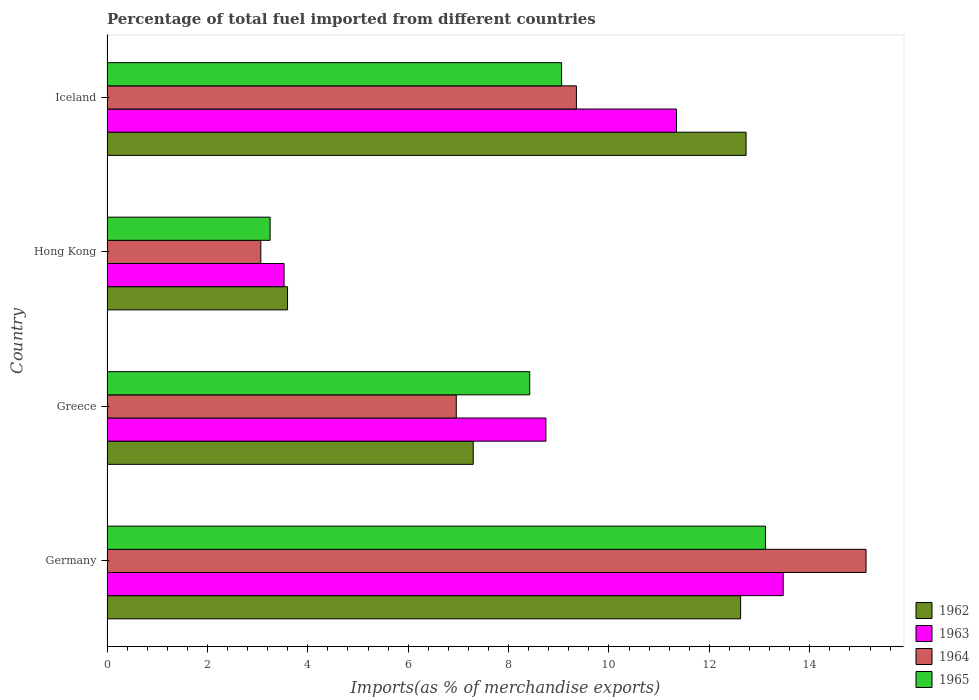How many different coloured bars are there?
Offer a very short reply. 4. How many groups of bars are there?
Ensure brevity in your answer.  4. What is the label of the 1st group of bars from the top?
Provide a short and direct response. Iceland. What is the percentage of imports to different countries in 1965 in Germany?
Provide a short and direct response. 13.12. Across all countries, what is the maximum percentage of imports to different countries in 1964?
Your answer should be compact. 15.12. Across all countries, what is the minimum percentage of imports to different countries in 1963?
Your answer should be compact. 3.53. In which country was the percentage of imports to different countries in 1965 maximum?
Provide a short and direct response. Germany. In which country was the percentage of imports to different countries in 1962 minimum?
Provide a short and direct response. Hong Kong. What is the total percentage of imports to different countries in 1964 in the graph?
Make the answer very short. 34.49. What is the difference between the percentage of imports to different countries in 1963 in Hong Kong and that in Iceland?
Ensure brevity in your answer.  -7.82. What is the difference between the percentage of imports to different countries in 1963 in Germany and the percentage of imports to different countries in 1962 in Hong Kong?
Provide a short and direct response. 9.87. What is the average percentage of imports to different countries in 1965 per country?
Your answer should be very brief. 8.46. What is the difference between the percentage of imports to different countries in 1965 and percentage of imports to different countries in 1962 in Greece?
Provide a succinct answer. 1.13. In how many countries, is the percentage of imports to different countries in 1965 greater than 4.8 %?
Provide a short and direct response. 3. What is the ratio of the percentage of imports to different countries in 1963 in Germany to that in Iceland?
Offer a very short reply. 1.19. What is the difference between the highest and the second highest percentage of imports to different countries in 1963?
Your answer should be very brief. 2.13. What is the difference between the highest and the lowest percentage of imports to different countries in 1962?
Offer a terse response. 9.13. Is the sum of the percentage of imports to different countries in 1964 in Greece and Hong Kong greater than the maximum percentage of imports to different countries in 1962 across all countries?
Ensure brevity in your answer.  No. Is it the case that in every country, the sum of the percentage of imports to different countries in 1965 and percentage of imports to different countries in 1963 is greater than the sum of percentage of imports to different countries in 1964 and percentage of imports to different countries in 1962?
Your response must be concise. No. What does the 2nd bar from the top in Hong Kong represents?
Offer a very short reply. 1964. Is it the case that in every country, the sum of the percentage of imports to different countries in 1962 and percentage of imports to different countries in 1965 is greater than the percentage of imports to different countries in 1963?
Ensure brevity in your answer.  Yes. How many bars are there?
Your answer should be compact. 16. How many countries are there in the graph?
Provide a succinct answer. 4. Does the graph contain grids?
Keep it short and to the point. No. Where does the legend appear in the graph?
Your answer should be very brief. Bottom right. How many legend labels are there?
Provide a short and direct response. 4. What is the title of the graph?
Give a very brief answer. Percentage of total fuel imported from different countries. What is the label or title of the X-axis?
Keep it short and to the point. Imports(as % of merchandise exports). What is the label or title of the Y-axis?
Your answer should be compact. Country. What is the Imports(as % of merchandise exports) in 1962 in Germany?
Your answer should be compact. 12.62. What is the Imports(as % of merchandise exports) in 1963 in Germany?
Your answer should be very brief. 13.47. What is the Imports(as % of merchandise exports) of 1964 in Germany?
Keep it short and to the point. 15.12. What is the Imports(as % of merchandise exports) of 1965 in Germany?
Provide a short and direct response. 13.12. What is the Imports(as % of merchandise exports) in 1962 in Greece?
Your answer should be compact. 7.3. What is the Imports(as % of merchandise exports) in 1963 in Greece?
Offer a very short reply. 8.74. What is the Imports(as % of merchandise exports) of 1964 in Greece?
Offer a terse response. 6.96. What is the Imports(as % of merchandise exports) in 1965 in Greece?
Offer a very short reply. 8.42. What is the Imports(as % of merchandise exports) of 1962 in Hong Kong?
Ensure brevity in your answer.  3.6. What is the Imports(as % of merchandise exports) in 1963 in Hong Kong?
Your answer should be compact. 3.53. What is the Imports(as % of merchandise exports) of 1964 in Hong Kong?
Give a very brief answer. 3.06. What is the Imports(as % of merchandise exports) of 1965 in Hong Kong?
Your answer should be compact. 3.25. What is the Imports(as % of merchandise exports) in 1962 in Iceland?
Offer a terse response. 12.73. What is the Imports(as % of merchandise exports) in 1963 in Iceland?
Your response must be concise. 11.35. What is the Imports(as % of merchandise exports) in 1964 in Iceland?
Offer a terse response. 9.35. What is the Imports(as % of merchandise exports) in 1965 in Iceland?
Ensure brevity in your answer.  9.06. Across all countries, what is the maximum Imports(as % of merchandise exports) of 1962?
Offer a very short reply. 12.73. Across all countries, what is the maximum Imports(as % of merchandise exports) of 1963?
Provide a succinct answer. 13.47. Across all countries, what is the maximum Imports(as % of merchandise exports) in 1964?
Provide a succinct answer. 15.12. Across all countries, what is the maximum Imports(as % of merchandise exports) of 1965?
Your answer should be very brief. 13.12. Across all countries, what is the minimum Imports(as % of merchandise exports) in 1962?
Ensure brevity in your answer.  3.6. Across all countries, what is the minimum Imports(as % of merchandise exports) in 1963?
Ensure brevity in your answer.  3.53. Across all countries, what is the minimum Imports(as % of merchandise exports) of 1964?
Your answer should be compact. 3.06. Across all countries, what is the minimum Imports(as % of merchandise exports) in 1965?
Your response must be concise. 3.25. What is the total Imports(as % of merchandise exports) of 1962 in the graph?
Your answer should be compact. 36.25. What is the total Imports(as % of merchandise exports) in 1963 in the graph?
Offer a very short reply. 37.09. What is the total Imports(as % of merchandise exports) of 1964 in the graph?
Make the answer very short. 34.49. What is the total Imports(as % of merchandise exports) in 1965 in the graph?
Offer a terse response. 33.84. What is the difference between the Imports(as % of merchandise exports) of 1962 in Germany and that in Greece?
Make the answer very short. 5.33. What is the difference between the Imports(as % of merchandise exports) in 1963 in Germany and that in Greece?
Give a very brief answer. 4.73. What is the difference between the Imports(as % of merchandise exports) of 1964 in Germany and that in Greece?
Your answer should be compact. 8.16. What is the difference between the Imports(as % of merchandise exports) in 1965 in Germany and that in Greece?
Make the answer very short. 4.7. What is the difference between the Imports(as % of merchandise exports) of 1962 in Germany and that in Hong Kong?
Ensure brevity in your answer.  9.03. What is the difference between the Imports(as % of merchandise exports) in 1963 in Germany and that in Hong Kong?
Ensure brevity in your answer.  9.94. What is the difference between the Imports(as % of merchandise exports) in 1964 in Germany and that in Hong Kong?
Give a very brief answer. 12.06. What is the difference between the Imports(as % of merchandise exports) of 1965 in Germany and that in Hong Kong?
Keep it short and to the point. 9.87. What is the difference between the Imports(as % of merchandise exports) in 1962 in Germany and that in Iceland?
Ensure brevity in your answer.  -0.11. What is the difference between the Imports(as % of merchandise exports) of 1963 in Germany and that in Iceland?
Offer a terse response. 2.13. What is the difference between the Imports(as % of merchandise exports) in 1964 in Germany and that in Iceland?
Your response must be concise. 5.77. What is the difference between the Imports(as % of merchandise exports) in 1965 in Germany and that in Iceland?
Offer a very short reply. 4.06. What is the difference between the Imports(as % of merchandise exports) of 1962 in Greece and that in Hong Kong?
Your response must be concise. 3.7. What is the difference between the Imports(as % of merchandise exports) of 1963 in Greece and that in Hong Kong?
Your response must be concise. 5.22. What is the difference between the Imports(as % of merchandise exports) of 1964 in Greece and that in Hong Kong?
Ensure brevity in your answer.  3.89. What is the difference between the Imports(as % of merchandise exports) of 1965 in Greece and that in Hong Kong?
Make the answer very short. 5.17. What is the difference between the Imports(as % of merchandise exports) of 1962 in Greece and that in Iceland?
Offer a terse response. -5.44. What is the difference between the Imports(as % of merchandise exports) of 1963 in Greece and that in Iceland?
Your answer should be compact. -2.6. What is the difference between the Imports(as % of merchandise exports) of 1964 in Greece and that in Iceland?
Give a very brief answer. -2.39. What is the difference between the Imports(as % of merchandise exports) of 1965 in Greece and that in Iceland?
Provide a short and direct response. -0.64. What is the difference between the Imports(as % of merchandise exports) in 1962 in Hong Kong and that in Iceland?
Give a very brief answer. -9.13. What is the difference between the Imports(as % of merchandise exports) of 1963 in Hong Kong and that in Iceland?
Offer a very short reply. -7.82. What is the difference between the Imports(as % of merchandise exports) of 1964 in Hong Kong and that in Iceland?
Ensure brevity in your answer.  -6.29. What is the difference between the Imports(as % of merchandise exports) in 1965 in Hong Kong and that in Iceland?
Offer a very short reply. -5.81. What is the difference between the Imports(as % of merchandise exports) in 1962 in Germany and the Imports(as % of merchandise exports) in 1963 in Greece?
Provide a short and direct response. 3.88. What is the difference between the Imports(as % of merchandise exports) in 1962 in Germany and the Imports(as % of merchandise exports) in 1964 in Greece?
Offer a very short reply. 5.66. What is the difference between the Imports(as % of merchandise exports) of 1962 in Germany and the Imports(as % of merchandise exports) of 1965 in Greece?
Keep it short and to the point. 4.2. What is the difference between the Imports(as % of merchandise exports) of 1963 in Germany and the Imports(as % of merchandise exports) of 1964 in Greece?
Provide a short and direct response. 6.51. What is the difference between the Imports(as % of merchandise exports) in 1963 in Germany and the Imports(as % of merchandise exports) in 1965 in Greece?
Your answer should be very brief. 5.05. What is the difference between the Imports(as % of merchandise exports) of 1964 in Germany and the Imports(as % of merchandise exports) of 1965 in Greece?
Ensure brevity in your answer.  6.7. What is the difference between the Imports(as % of merchandise exports) of 1962 in Germany and the Imports(as % of merchandise exports) of 1963 in Hong Kong?
Provide a short and direct response. 9.1. What is the difference between the Imports(as % of merchandise exports) in 1962 in Germany and the Imports(as % of merchandise exports) in 1964 in Hong Kong?
Your answer should be compact. 9.56. What is the difference between the Imports(as % of merchandise exports) of 1962 in Germany and the Imports(as % of merchandise exports) of 1965 in Hong Kong?
Offer a terse response. 9.37. What is the difference between the Imports(as % of merchandise exports) in 1963 in Germany and the Imports(as % of merchandise exports) in 1964 in Hong Kong?
Offer a very short reply. 10.41. What is the difference between the Imports(as % of merchandise exports) of 1963 in Germany and the Imports(as % of merchandise exports) of 1965 in Hong Kong?
Give a very brief answer. 10.22. What is the difference between the Imports(as % of merchandise exports) of 1964 in Germany and the Imports(as % of merchandise exports) of 1965 in Hong Kong?
Offer a terse response. 11.87. What is the difference between the Imports(as % of merchandise exports) in 1962 in Germany and the Imports(as % of merchandise exports) in 1963 in Iceland?
Offer a very short reply. 1.28. What is the difference between the Imports(as % of merchandise exports) in 1962 in Germany and the Imports(as % of merchandise exports) in 1964 in Iceland?
Offer a very short reply. 3.27. What is the difference between the Imports(as % of merchandise exports) in 1962 in Germany and the Imports(as % of merchandise exports) in 1965 in Iceland?
Offer a very short reply. 3.57. What is the difference between the Imports(as % of merchandise exports) in 1963 in Germany and the Imports(as % of merchandise exports) in 1964 in Iceland?
Provide a short and direct response. 4.12. What is the difference between the Imports(as % of merchandise exports) of 1963 in Germany and the Imports(as % of merchandise exports) of 1965 in Iceland?
Your answer should be very brief. 4.41. What is the difference between the Imports(as % of merchandise exports) in 1964 in Germany and the Imports(as % of merchandise exports) in 1965 in Iceland?
Ensure brevity in your answer.  6.06. What is the difference between the Imports(as % of merchandise exports) of 1962 in Greece and the Imports(as % of merchandise exports) of 1963 in Hong Kong?
Your answer should be compact. 3.77. What is the difference between the Imports(as % of merchandise exports) of 1962 in Greece and the Imports(as % of merchandise exports) of 1964 in Hong Kong?
Provide a succinct answer. 4.23. What is the difference between the Imports(as % of merchandise exports) in 1962 in Greece and the Imports(as % of merchandise exports) in 1965 in Hong Kong?
Provide a succinct answer. 4.05. What is the difference between the Imports(as % of merchandise exports) in 1963 in Greece and the Imports(as % of merchandise exports) in 1964 in Hong Kong?
Ensure brevity in your answer.  5.68. What is the difference between the Imports(as % of merchandise exports) of 1963 in Greece and the Imports(as % of merchandise exports) of 1965 in Hong Kong?
Your response must be concise. 5.49. What is the difference between the Imports(as % of merchandise exports) of 1964 in Greece and the Imports(as % of merchandise exports) of 1965 in Hong Kong?
Offer a terse response. 3.71. What is the difference between the Imports(as % of merchandise exports) of 1962 in Greece and the Imports(as % of merchandise exports) of 1963 in Iceland?
Your response must be concise. -4.05. What is the difference between the Imports(as % of merchandise exports) of 1962 in Greece and the Imports(as % of merchandise exports) of 1964 in Iceland?
Offer a very short reply. -2.06. What is the difference between the Imports(as % of merchandise exports) of 1962 in Greece and the Imports(as % of merchandise exports) of 1965 in Iceland?
Provide a short and direct response. -1.76. What is the difference between the Imports(as % of merchandise exports) of 1963 in Greece and the Imports(as % of merchandise exports) of 1964 in Iceland?
Provide a short and direct response. -0.61. What is the difference between the Imports(as % of merchandise exports) in 1963 in Greece and the Imports(as % of merchandise exports) in 1965 in Iceland?
Keep it short and to the point. -0.31. What is the difference between the Imports(as % of merchandise exports) in 1964 in Greece and the Imports(as % of merchandise exports) in 1965 in Iceland?
Offer a terse response. -2.1. What is the difference between the Imports(as % of merchandise exports) in 1962 in Hong Kong and the Imports(as % of merchandise exports) in 1963 in Iceland?
Provide a succinct answer. -7.75. What is the difference between the Imports(as % of merchandise exports) in 1962 in Hong Kong and the Imports(as % of merchandise exports) in 1964 in Iceland?
Provide a short and direct response. -5.75. What is the difference between the Imports(as % of merchandise exports) of 1962 in Hong Kong and the Imports(as % of merchandise exports) of 1965 in Iceland?
Offer a terse response. -5.46. What is the difference between the Imports(as % of merchandise exports) in 1963 in Hong Kong and the Imports(as % of merchandise exports) in 1964 in Iceland?
Make the answer very short. -5.82. What is the difference between the Imports(as % of merchandise exports) of 1963 in Hong Kong and the Imports(as % of merchandise exports) of 1965 in Iceland?
Make the answer very short. -5.53. What is the difference between the Imports(as % of merchandise exports) in 1964 in Hong Kong and the Imports(as % of merchandise exports) in 1965 in Iceland?
Your answer should be compact. -5.99. What is the average Imports(as % of merchandise exports) of 1962 per country?
Your answer should be compact. 9.06. What is the average Imports(as % of merchandise exports) in 1963 per country?
Provide a succinct answer. 9.27. What is the average Imports(as % of merchandise exports) of 1964 per country?
Ensure brevity in your answer.  8.62. What is the average Imports(as % of merchandise exports) in 1965 per country?
Offer a very short reply. 8.46. What is the difference between the Imports(as % of merchandise exports) in 1962 and Imports(as % of merchandise exports) in 1963 in Germany?
Provide a succinct answer. -0.85. What is the difference between the Imports(as % of merchandise exports) of 1962 and Imports(as % of merchandise exports) of 1964 in Germany?
Keep it short and to the point. -2.5. What is the difference between the Imports(as % of merchandise exports) in 1962 and Imports(as % of merchandise exports) in 1965 in Germany?
Give a very brief answer. -0.49. What is the difference between the Imports(as % of merchandise exports) of 1963 and Imports(as % of merchandise exports) of 1964 in Germany?
Ensure brevity in your answer.  -1.65. What is the difference between the Imports(as % of merchandise exports) in 1963 and Imports(as % of merchandise exports) in 1965 in Germany?
Your answer should be compact. 0.35. What is the difference between the Imports(as % of merchandise exports) of 1964 and Imports(as % of merchandise exports) of 1965 in Germany?
Your answer should be compact. 2. What is the difference between the Imports(as % of merchandise exports) in 1962 and Imports(as % of merchandise exports) in 1963 in Greece?
Keep it short and to the point. -1.45. What is the difference between the Imports(as % of merchandise exports) in 1962 and Imports(as % of merchandise exports) in 1964 in Greece?
Your response must be concise. 0.34. What is the difference between the Imports(as % of merchandise exports) in 1962 and Imports(as % of merchandise exports) in 1965 in Greece?
Provide a succinct answer. -1.13. What is the difference between the Imports(as % of merchandise exports) of 1963 and Imports(as % of merchandise exports) of 1964 in Greece?
Keep it short and to the point. 1.79. What is the difference between the Imports(as % of merchandise exports) of 1963 and Imports(as % of merchandise exports) of 1965 in Greece?
Give a very brief answer. 0.32. What is the difference between the Imports(as % of merchandise exports) of 1964 and Imports(as % of merchandise exports) of 1965 in Greece?
Your answer should be very brief. -1.46. What is the difference between the Imports(as % of merchandise exports) in 1962 and Imports(as % of merchandise exports) in 1963 in Hong Kong?
Ensure brevity in your answer.  0.07. What is the difference between the Imports(as % of merchandise exports) of 1962 and Imports(as % of merchandise exports) of 1964 in Hong Kong?
Give a very brief answer. 0.53. What is the difference between the Imports(as % of merchandise exports) of 1962 and Imports(as % of merchandise exports) of 1965 in Hong Kong?
Offer a very short reply. 0.35. What is the difference between the Imports(as % of merchandise exports) in 1963 and Imports(as % of merchandise exports) in 1964 in Hong Kong?
Offer a very short reply. 0.46. What is the difference between the Imports(as % of merchandise exports) in 1963 and Imports(as % of merchandise exports) in 1965 in Hong Kong?
Offer a terse response. 0.28. What is the difference between the Imports(as % of merchandise exports) of 1964 and Imports(as % of merchandise exports) of 1965 in Hong Kong?
Provide a short and direct response. -0.19. What is the difference between the Imports(as % of merchandise exports) of 1962 and Imports(as % of merchandise exports) of 1963 in Iceland?
Make the answer very short. 1.39. What is the difference between the Imports(as % of merchandise exports) of 1962 and Imports(as % of merchandise exports) of 1964 in Iceland?
Your answer should be compact. 3.38. What is the difference between the Imports(as % of merchandise exports) in 1962 and Imports(as % of merchandise exports) in 1965 in Iceland?
Your response must be concise. 3.67. What is the difference between the Imports(as % of merchandise exports) of 1963 and Imports(as % of merchandise exports) of 1964 in Iceland?
Ensure brevity in your answer.  1.99. What is the difference between the Imports(as % of merchandise exports) in 1963 and Imports(as % of merchandise exports) in 1965 in Iceland?
Your answer should be compact. 2.29. What is the difference between the Imports(as % of merchandise exports) in 1964 and Imports(as % of merchandise exports) in 1965 in Iceland?
Give a very brief answer. 0.29. What is the ratio of the Imports(as % of merchandise exports) of 1962 in Germany to that in Greece?
Give a very brief answer. 1.73. What is the ratio of the Imports(as % of merchandise exports) of 1963 in Germany to that in Greece?
Keep it short and to the point. 1.54. What is the ratio of the Imports(as % of merchandise exports) in 1964 in Germany to that in Greece?
Ensure brevity in your answer.  2.17. What is the ratio of the Imports(as % of merchandise exports) in 1965 in Germany to that in Greece?
Your answer should be compact. 1.56. What is the ratio of the Imports(as % of merchandise exports) of 1962 in Germany to that in Hong Kong?
Offer a terse response. 3.51. What is the ratio of the Imports(as % of merchandise exports) of 1963 in Germany to that in Hong Kong?
Give a very brief answer. 3.82. What is the ratio of the Imports(as % of merchandise exports) in 1964 in Germany to that in Hong Kong?
Your answer should be very brief. 4.94. What is the ratio of the Imports(as % of merchandise exports) of 1965 in Germany to that in Hong Kong?
Offer a terse response. 4.04. What is the ratio of the Imports(as % of merchandise exports) of 1962 in Germany to that in Iceland?
Offer a very short reply. 0.99. What is the ratio of the Imports(as % of merchandise exports) in 1963 in Germany to that in Iceland?
Your answer should be compact. 1.19. What is the ratio of the Imports(as % of merchandise exports) of 1964 in Germany to that in Iceland?
Make the answer very short. 1.62. What is the ratio of the Imports(as % of merchandise exports) in 1965 in Germany to that in Iceland?
Your response must be concise. 1.45. What is the ratio of the Imports(as % of merchandise exports) of 1962 in Greece to that in Hong Kong?
Provide a succinct answer. 2.03. What is the ratio of the Imports(as % of merchandise exports) of 1963 in Greece to that in Hong Kong?
Keep it short and to the point. 2.48. What is the ratio of the Imports(as % of merchandise exports) in 1964 in Greece to that in Hong Kong?
Give a very brief answer. 2.27. What is the ratio of the Imports(as % of merchandise exports) in 1965 in Greece to that in Hong Kong?
Keep it short and to the point. 2.59. What is the ratio of the Imports(as % of merchandise exports) in 1962 in Greece to that in Iceland?
Make the answer very short. 0.57. What is the ratio of the Imports(as % of merchandise exports) of 1963 in Greece to that in Iceland?
Ensure brevity in your answer.  0.77. What is the ratio of the Imports(as % of merchandise exports) in 1964 in Greece to that in Iceland?
Offer a terse response. 0.74. What is the ratio of the Imports(as % of merchandise exports) of 1965 in Greece to that in Iceland?
Give a very brief answer. 0.93. What is the ratio of the Imports(as % of merchandise exports) of 1962 in Hong Kong to that in Iceland?
Give a very brief answer. 0.28. What is the ratio of the Imports(as % of merchandise exports) of 1963 in Hong Kong to that in Iceland?
Give a very brief answer. 0.31. What is the ratio of the Imports(as % of merchandise exports) of 1964 in Hong Kong to that in Iceland?
Your response must be concise. 0.33. What is the ratio of the Imports(as % of merchandise exports) in 1965 in Hong Kong to that in Iceland?
Ensure brevity in your answer.  0.36. What is the difference between the highest and the second highest Imports(as % of merchandise exports) of 1962?
Keep it short and to the point. 0.11. What is the difference between the highest and the second highest Imports(as % of merchandise exports) in 1963?
Give a very brief answer. 2.13. What is the difference between the highest and the second highest Imports(as % of merchandise exports) in 1964?
Ensure brevity in your answer.  5.77. What is the difference between the highest and the second highest Imports(as % of merchandise exports) of 1965?
Your answer should be very brief. 4.06. What is the difference between the highest and the lowest Imports(as % of merchandise exports) of 1962?
Give a very brief answer. 9.13. What is the difference between the highest and the lowest Imports(as % of merchandise exports) in 1963?
Make the answer very short. 9.94. What is the difference between the highest and the lowest Imports(as % of merchandise exports) in 1964?
Offer a terse response. 12.06. What is the difference between the highest and the lowest Imports(as % of merchandise exports) in 1965?
Make the answer very short. 9.87. 